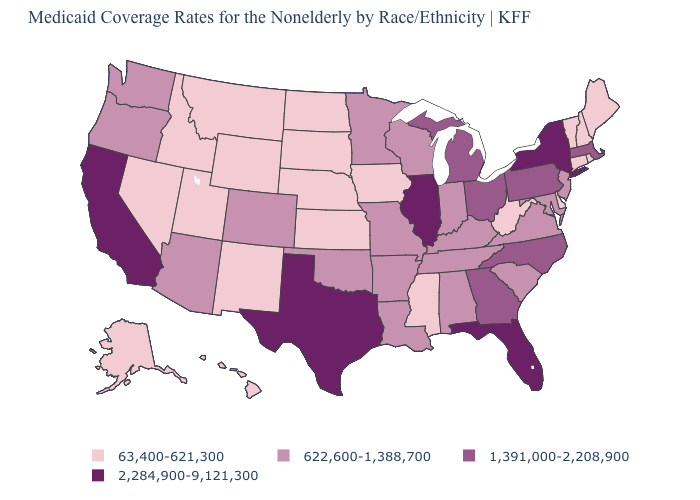Does Vermont have the highest value in the USA?
Write a very short answer. No. What is the value of Pennsylvania?
Write a very short answer. 1,391,000-2,208,900. Among the states that border Oregon , which have the highest value?
Concise answer only. California. Which states have the lowest value in the USA?
Short answer required. Alaska, Connecticut, Delaware, Hawaii, Idaho, Iowa, Kansas, Maine, Mississippi, Montana, Nebraska, Nevada, New Hampshire, New Mexico, North Dakota, Rhode Island, South Dakota, Utah, Vermont, West Virginia, Wyoming. Which states have the highest value in the USA?
Answer briefly. California, Florida, Illinois, New York, Texas. Name the states that have a value in the range 2,284,900-9,121,300?
Be succinct. California, Florida, Illinois, New York, Texas. What is the value of South Carolina?
Write a very short answer. 622,600-1,388,700. What is the value of New Hampshire?
Concise answer only. 63,400-621,300. Which states have the lowest value in the Northeast?
Write a very short answer. Connecticut, Maine, New Hampshire, Rhode Island, Vermont. What is the value of Delaware?
Write a very short answer. 63,400-621,300. What is the value of Alaska?
Quick response, please. 63,400-621,300. Which states have the lowest value in the MidWest?
Be succinct. Iowa, Kansas, Nebraska, North Dakota, South Dakota. Name the states that have a value in the range 2,284,900-9,121,300?
Answer briefly. California, Florida, Illinois, New York, Texas. What is the value of Ohio?
Short answer required. 1,391,000-2,208,900. What is the value of Maine?
Answer briefly. 63,400-621,300. 